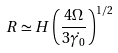<formula> <loc_0><loc_0><loc_500><loc_500>R \simeq H \left ( \frac { 4 \Omega } { 3 \dot { \gamma _ { 0 } } } \right ) ^ { 1 / 2 }</formula> 